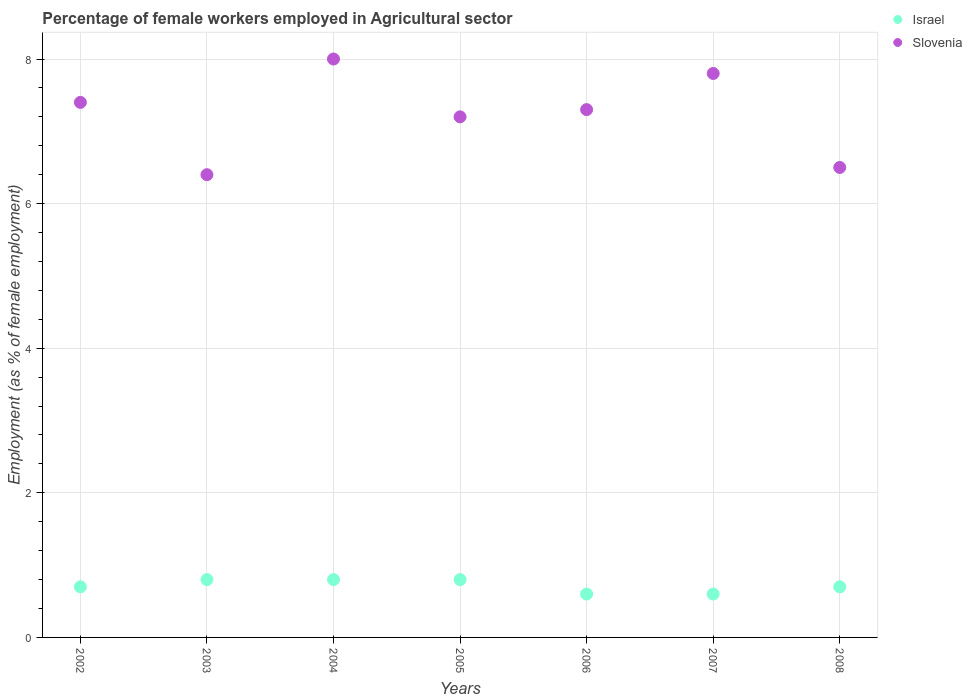What is the percentage of females employed in Agricultural sector in Israel in 2007?
Your answer should be compact. 0.6. Across all years, what is the minimum percentage of females employed in Agricultural sector in Israel?
Ensure brevity in your answer.  0.6. In which year was the percentage of females employed in Agricultural sector in Israel maximum?
Provide a succinct answer. 2003. What is the total percentage of females employed in Agricultural sector in Israel in the graph?
Give a very brief answer. 5. What is the difference between the percentage of females employed in Agricultural sector in Israel in 2002 and that in 2005?
Make the answer very short. -0.1. What is the difference between the percentage of females employed in Agricultural sector in Slovenia in 2007 and the percentage of females employed in Agricultural sector in Israel in 2008?
Your answer should be very brief. 7.1. What is the average percentage of females employed in Agricultural sector in Slovenia per year?
Your answer should be compact. 7.23. In the year 2002, what is the difference between the percentage of females employed in Agricultural sector in Israel and percentage of females employed in Agricultural sector in Slovenia?
Ensure brevity in your answer.  -6.7. In how many years, is the percentage of females employed in Agricultural sector in Israel greater than 1.6 %?
Make the answer very short. 0. What is the ratio of the percentage of females employed in Agricultural sector in Israel in 2002 to that in 2006?
Provide a short and direct response. 1.17. What is the difference between the highest and the second highest percentage of females employed in Agricultural sector in Slovenia?
Provide a succinct answer. 0.2. What is the difference between the highest and the lowest percentage of females employed in Agricultural sector in Israel?
Make the answer very short. 0.2. Is the sum of the percentage of females employed in Agricultural sector in Slovenia in 2003 and 2005 greater than the maximum percentage of females employed in Agricultural sector in Israel across all years?
Make the answer very short. Yes. Does the percentage of females employed in Agricultural sector in Israel monotonically increase over the years?
Your answer should be compact. No. Is the percentage of females employed in Agricultural sector in Slovenia strictly greater than the percentage of females employed in Agricultural sector in Israel over the years?
Your answer should be compact. Yes. How many dotlines are there?
Keep it short and to the point. 2. Does the graph contain any zero values?
Offer a terse response. No. How many legend labels are there?
Offer a terse response. 2. How are the legend labels stacked?
Offer a terse response. Vertical. What is the title of the graph?
Ensure brevity in your answer.  Percentage of female workers employed in Agricultural sector. What is the label or title of the Y-axis?
Offer a terse response. Employment (as % of female employment). What is the Employment (as % of female employment) in Israel in 2002?
Your response must be concise. 0.7. What is the Employment (as % of female employment) in Slovenia in 2002?
Offer a very short reply. 7.4. What is the Employment (as % of female employment) in Israel in 2003?
Make the answer very short. 0.8. What is the Employment (as % of female employment) of Slovenia in 2003?
Offer a terse response. 6.4. What is the Employment (as % of female employment) of Israel in 2004?
Make the answer very short. 0.8. What is the Employment (as % of female employment) of Israel in 2005?
Offer a terse response. 0.8. What is the Employment (as % of female employment) of Slovenia in 2005?
Keep it short and to the point. 7.2. What is the Employment (as % of female employment) of Israel in 2006?
Keep it short and to the point. 0.6. What is the Employment (as % of female employment) in Slovenia in 2006?
Provide a short and direct response. 7.3. What is the Employment (as % of female employment) of Israel in 2007?
Provide a short and direct response. 0.6. What is the Employment (as % of female employment) in Slovenia in 2007?
Your answer should be compact. 7.8. What is the Employment (as % of female employment) in Israel in 2008?
Ensure brevity in your answer.  0.7. What is the Employment (as % of female employment) of Slovenia in 2008?
Make the answer very short. 6.5. Across all years, what is the maximum Employment (as % of female employment) of Israel?
Provide a succinct answer. 0.8. Across all years, what is the maximum Employment (as % of female employment) in Slovenia?
Keep it short and to the point. 8. Across all years, what is the minimum Employment (as % of female employment) in Israel?
Your answer should be very brief. 0.6. Across all years, what is the minimum Employment (as % of female employment) of Slovenia?
Your response must be concise. 6.4. What is the total Employment (as % of female employment) in Israel in the graph?
Give a very brief answer. 5. What is the total Employment (as % of female employment) in Slovenia in the graph?
Provide a short and direct response. 50.6. What is the difference between the Employment (as % of female employment) in Israel in 2002 and that in 2003?
Your response must be concise. -0.1. What is the difference between the Employment (as % of female employment) in Slovenia in 2002 and that in 2003?
Provide a short and direct response. 1. What is the difference between the Employment (as % of female employment) of Slovenia in 2002 and that in 2004?
Make the answer very short. -0.6. What is the difference between the Employment (as % of female employment) of Slovenia in 2002 and that in 2005?
Give a very brief answer. 0.2. What is the difference between the Employment (as % of female employment) of Israel in 2002 and that in 2006?
Your response must be concise. 0.1. What is the difference between the Employment (as % of female employment) of Slovenia in 2002 and that in 2006?
Ensure brevity in your answer.  0.1. What is the difference between the Employment (as % of female employment) in Slovenia in 2003 and that in 2004?
Make the answer very short. -1.6. What is the difference between the Employment (as % of female employment) in Israel in 2003 and that in 2006?
Provide a succinct answer. 0.2. What is the difference between the Employment (as % of female employment) of Slovenia in 2003 and that in 2006?
Ensure brevity in your answer.  -0.9. What is the difference between the Employment (as % of female employment) of Slovenia in 2003 and that in 2007?
Keep it short and to the point. -1.4. What is the difference between the Employment (as % of female employment) of Slovenia in 2003 and that in 2008?
Offer a terse response. -0.1. What is the difference between the Employment (as % of female employment) of Slovenia in 2004 and that in 2005?
Offer a terse response. 0.8. What is the difference between the Employment (as % of female employment) of Israel in 2004 and that in 2006?
Provide a short and direct response. 0.2. What is the difference between the Employment (as % of female employment) in Israel in 2004 and that in 2007?
Provide a short and direct response. 0.2. What is the difference between the Employment (as % of female employment) of Israel in 2004 and that in 2008?
Make the answer very short. 0.1. What is the difference between the Employment (as % of female employment) in Slovenia in 2004 and that in 2008?
Ensure brevity in your answer.  1.5. What is the difference between the Employment (as % of female employment) in Israel in 2005 and that in 2006?
Your answer should be very brief. 0.2. What is the difference between the Employment (as % of female employment) of Slovenia in 2005 and that in 2006?
Your response must be concise. -0.1. What is the difference between the Employment (as % of female employment) in Israel in 2005 and that in 2008?
Your answer should be compact. 0.1. What is the difference between the Employment (as % of female employment) of Israel in 2006 and that in 2007?
Your answer should be compact. 0. What is the difference between the Employment (as % of female employment) in Israel in 2006 and that in 2008?
Your response must be concise. -0.1. What is the difference between the Employment (as % of female employment) of Israel in 2007 and that in 2008?
Offer a very short reply. -0.1. What is the difference between the Employment (as % of female employment) of Israel in 2002 and the Employment (as % of female employment) of Slovenia in 2003?
Your response must be concise. -5.7. What is the difference between the Employment (as % of female employment) in Israel in 2002 and the Employment (as % of female employment) in Slovenia in 2006?
Offer a terse response. -6.6. What is the difference between the Employment (as % of female employment) of Israel in 2002 and the Employment (as % of female employment) of Slovenia in 2007?
Your answer should be compact. -7.1. What is the difference between the Employment (as % of female employment) in Israel in 2003 and the Employment (as % of female employment) in Slovenia in 2004?
Provide a short and direct response. -7.2. What is the difference between the Employment (as % of female employment) of Israel in 2003 and the Employment (as % of female employment) of Slovenia in 2006?
Offer a terse response. -6.5. What is the difference between the Employment (as % of female employment) of Israel in 2003 and the Employment (as % of female employment) of Slovenia in 2007?
Provide a succinct answer. -7. What is the difference between the Employment (as % of female employment) in Israel in 2004 and the Employment (as % of female employment) in Slovenia in 2005?
Keep it short and to the point. -6.4. What is the difference between the Employment (as % of female employment) in Israel in 2004 and the Employment (as % of female employment) in Slovenia in 2008?
Provide a succinct answer. -5.7. What is the difference between the Employment (as % of female employment) in Israel in 2005 and the Employment (as % of female employment) in Slovenia in 2007?
Keep it short and to the point. -7. What is the difference between the Employment (as % of female employment) of Israel in 2006 and the Employment (as % of female employment) of Slovenia in 2007?
Ensure brevity in your answer.  -7.2. What is the average Employment (as % of female employment) in Israel per year?
Provide a short and direct response. 0.71. What is the average Employment (as % of female employment) of Slovenia per year?
Your response must be concise. 7.23. In the year 2002, what is the difference between the Employment (as % of female employment) of Israel and Employment (as % of female employment) of Slovenia?
Make the answer very short. -6.7. In the year 2007, what is the difference between the Employment (as % of female employment) of Israel and Employment (as % of female employment) of Slovenia?
Offer a terse response. -7.2. In the year 2008, what is the difference between the Employment (as % of female employment) in Israel and Employment (as % of female employment) in Slovenia?
Offer a very short reply. -5.8. What is the ratio of the Employment (as % of female employment) of Israel in 2002 to that in 2003?
Provide a succinct answer. 0.88. What is the ratio of the Employment (as % of female employment) of Slovenia in 2002 to that in 2003?
Give a very brief answer. 1.16. What is the ratio of the Employment (as % of female employment) of Slovenia in 2002 to that in 2004?
Keep it short and to the point. 0.93. What is the ratio of the Employment (as % of female employment) in Israel in 2002 to that in 2005?
Offer a very short reply. 0.88. What is the ratio of the Employment (as % of female employment) of Slovenia in 2002 to that in 2005?
Offer a terse response. 1.03. What is the ratio of the Employment (as % of female employment) of Slovenia in 2002 to that in 2006?
Provide a short and direct response. 1.01. What is the ratio of the Employment (as % of female employment) in Israel in 2002 to that in 2007?
Your answer should be very brief. 1.17. What is the ratio of the Employment (as % of female employment) in Slovenia in 2002 to that in 2007?
Keep it short and to the point. 0.95. What is the ratio of the Employment (as % of female employment) of Israel in 2002 to that in 2008?
Provide a succinct answer. 1. What is the ratio of the Employment (as % of female employment) in Slovenia in 2002 to that in 2008?
Your response must be concise. 1.14. What is the ratio of the Employment (as % of female employment) in Israel in 2003 to that in 2004?
Keep it short and to the point. 1. What is the ratio of the Employment (as % of female employment) of Slovenia in 2003 to that in 2006?
Your answer should be very brief. 0.88. What is the ratio of the Employment (as % of female employment) in Israel in 2003 to that in 2007?
Provide a short and direct response. 1.33. What is the ratio of the Employment (as % of female employment) in Slovenia in 2003 to that in 2007?
Your response must be concise. 0.82. What is the ratio of the Employment (as % of female employment) in Israel in 2003 to that in 2008?
Your answer should be compact. 1.14. What is the ratio of the Employment (as % of female employment) of Slovenia in 2003 to that in 2008?
Offer a very short reply. 0.98. What is the ratio of the Employment (as % of female employment) of Israel in 2004 to that in 2005?
Offer a very short reply. 1. What is the ratio of the Employment (as % of female employment) in Slovenia in 2004 to that in 2005?
Give a very brief answer. 1.11. What is the ratio of the Employment (as % of female employment) in Slovenia in 2004 to that in 2006?
Provide a short and direct response. 1.1. What is the ratio of the Employment (as % of female employment) of Israel in 2004 to that in 2007?
Offer a terse response. 1.33. What is the ratio of the Employment (as % of female employment) in Slovenia in 2004 to that in 2007?
Make the answer very short. 1.03. What is the ratio of the Employment (as % of female employment) in Slovenia in 2004 to that in 2008?
Give a very brief answer. 1.23. What is the ratio of the Employment (as % of female employment) of Israel in 2005 to that in 2006?
Make the answer very short. 1.33. What is the ratio of the Employment (as % of female employment) in Slovenia in 2005 to that in 2006?
Keep it short and to the point. 0.99. What is the ratio of the Employment (as % of female employment) of Israel in 2005 to that in 2007?
Provide a short and direct response. 1.33. What is the ratio of the Employment (as % of female employment) of Slovenia in 2005 to that in 2007?
Ensure brevity in your answer.  0.92. What is the ratio of the Employment (as % of female employment) in Israel in 2005 to that in 2008?
Offer a very short reply. 1.14. What is the ratio of the Employment (as % of female employment) in Slovenia in 2005 to that in 2008?
Your answer should be compact. 1.11. What is the ratio of the Employment (as % of female employment) in Slovenia in 2006 to that in 2007?
Your response must be concise. 0.94. What is the ratio of the Employment (as % of female employment) in Israel in 2006 to that in 2008?
Your answer should be very brief. 0.86. What is the ratio of the Employment (as % of female employment) in Slovenia in 2006 to that in 2008?
Offer a very short reply. 1.12. What is the ratio of the Employment (as % of female employment) in Israel in 2007 to that in 2008?
Provide a succinct answer. 0.86. What is the difference between the highest and the second highest Employment (as % of female employment) of Israel?
Keep it short and to the point. 0. What is the difference between the highest and the lowest Employment (as % of female employment) of Israel?
Give a very brief answer. 0.2. 